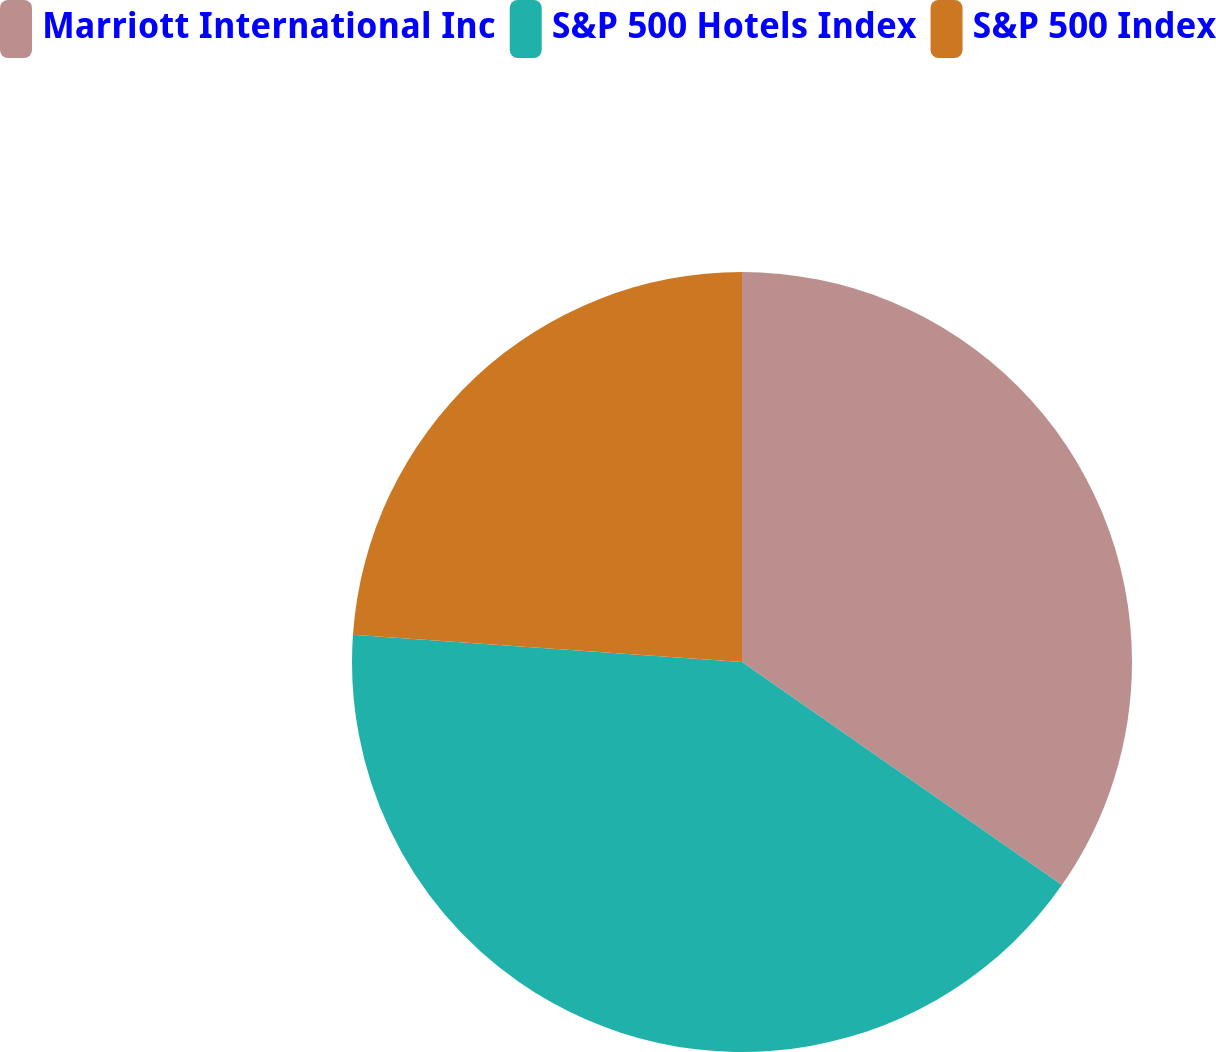Convert chart. <chart><loc_0><loc_0><loc_500><loc_500><pie_chart><fcel>Marriott International Inc<fcel>S&P 500 Hotels Index<fcel>S&P 500 Index<nl><fcel>34.69%<fcel>41.42%<fcel>23.89%<nl></chart> 